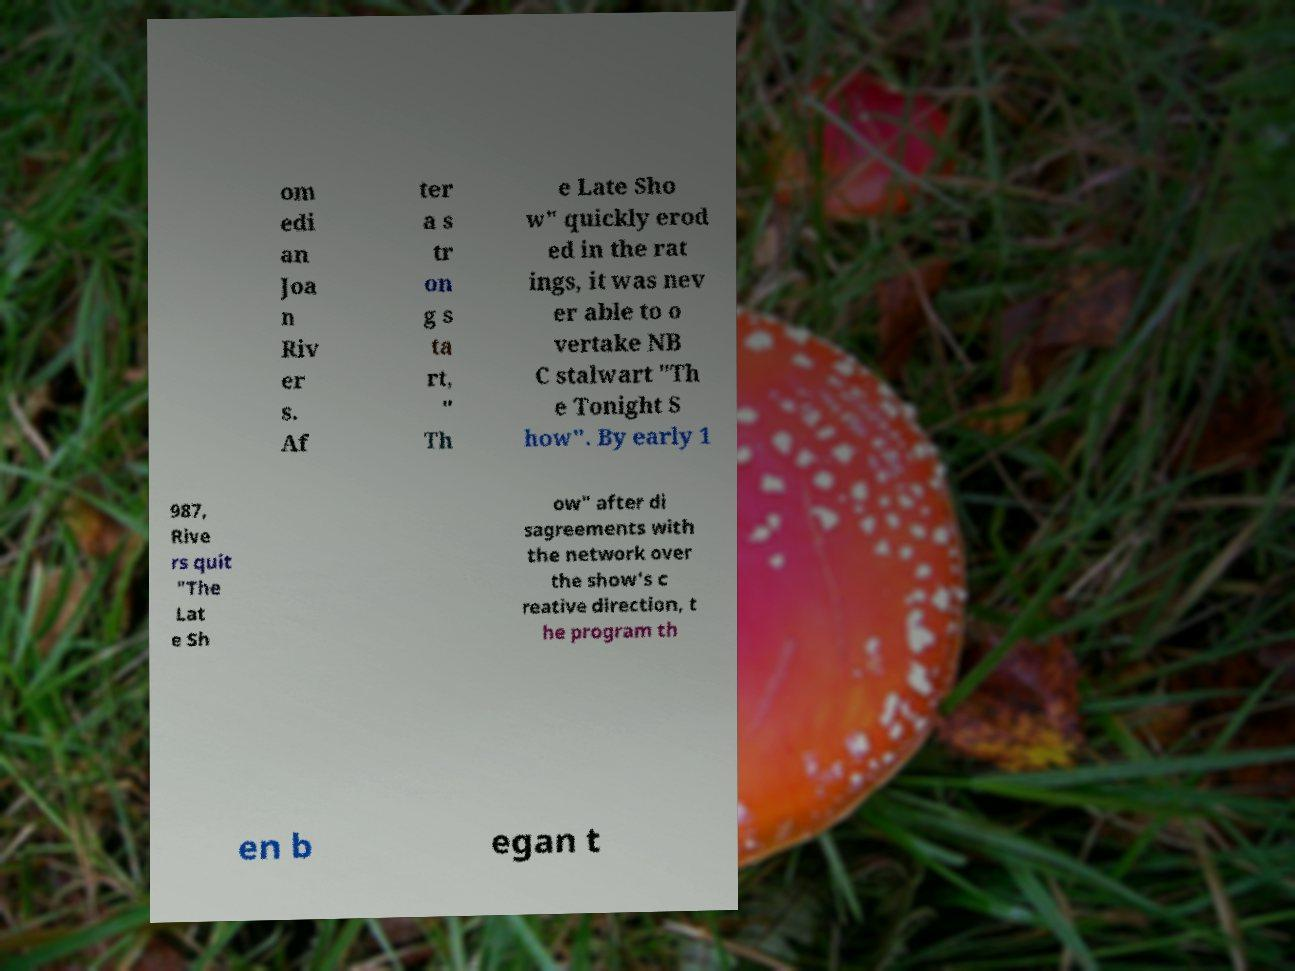Could you assist in decoding the text presented in this image and type it out clearly? om edi an Joa n Riv er s. Af ter a s tr on g s ta rt, " Th e Late Sho w" quickly erod ed in the rat ings, it was nev er able to o vertake NB C stalwart "Th e Tonight S how". By early 1 987, Rive rs quit "The Lat e Sh ow" after di sagreements with the network over the show's c reative direction, t he program th en b egan t 